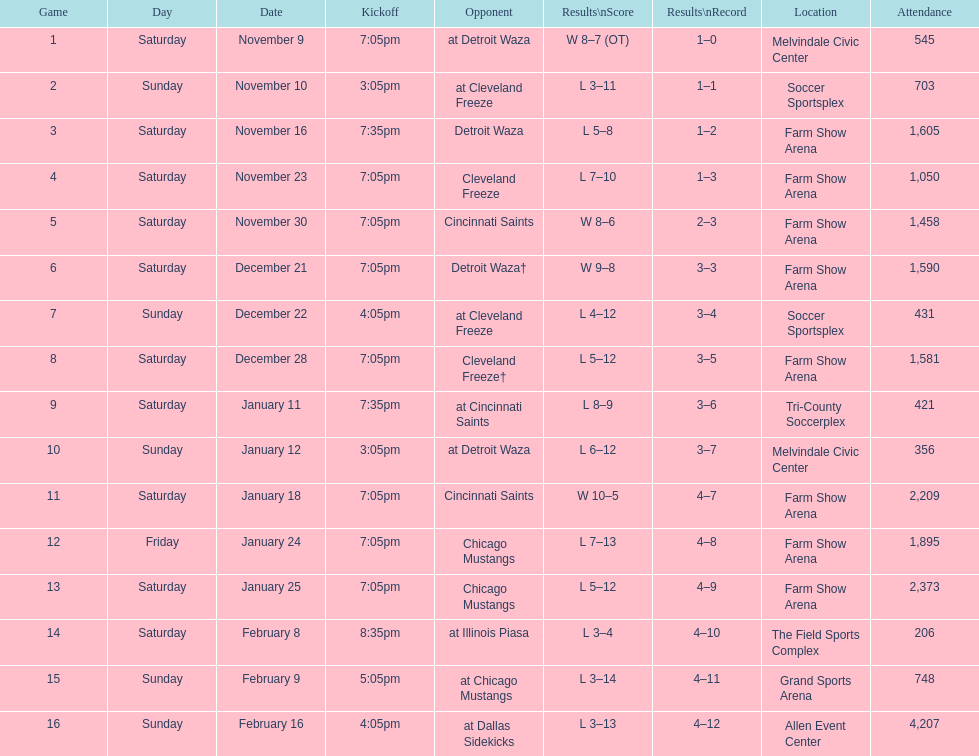How often did the team participate in home games without achieving a win? 5. 